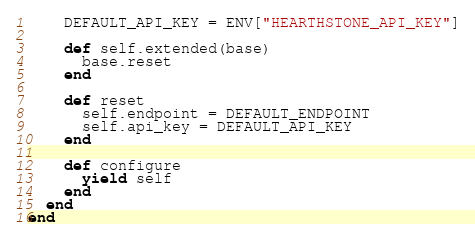<code> <loc_0><loc_0><loc_500><loc_500><_Ruby_>    DEFAULT_API_KEY = ENV["HEARTHSTONE_API_KEY"]

    def self.extended(base)
      base.reset
    end

    def reset
      self.endpoint = DEFAULT_ENDPOINT
      self.api_key = DEFAULT_API_KEY
    end

    def configure
      yield self
    end
  end
end
</code> 